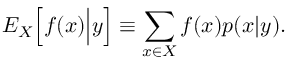Convert formula to latex. <formula><loc_0><loc_0><loc_500><loc_500>{ E } _ { X } \Big [ f ( x ) \Big | y \Big ] \equiv \sum _ { x \in X } f ( x ) p ( x | y ) .</formula> 